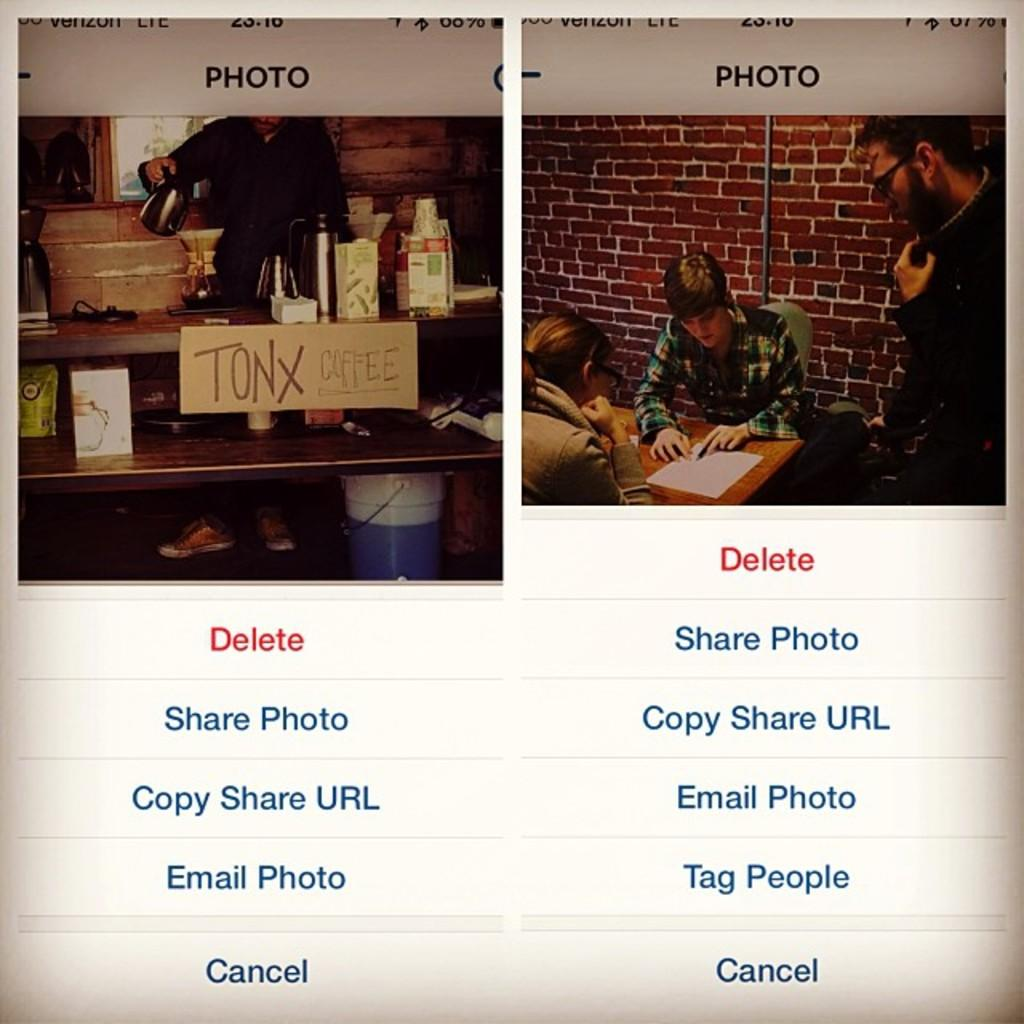<image>
Describe the image concisely. Options on a web page include Share Photo, Email Photo and Tag People. 